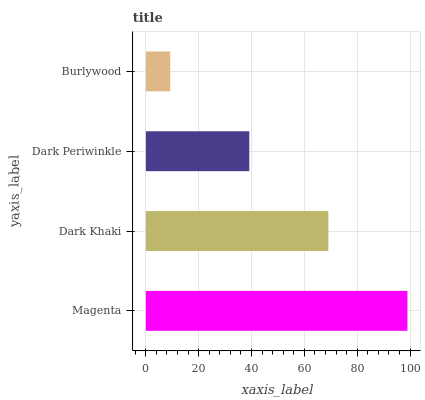Is Burlywood the minimum?
Answer yes or no. Yes. Is Magenta the maximum?
Answer yes or no. Yes. Is Dark Khaki the minimum?
Answer yes or no. No. Is Dark Khaki the maximum?
Answer yes or no. No. Is Magenta greater than Dark Khaki?
Answer yes or no. Yes. Is Dark Khaki less than Magenta?
Answer yes or no. Yes. Is Dark Khaki greater than Magenta?
Answer yes or no. No. Is Magenta less than Dark Khaki?
Answer yes or no. No. Is Dark Khaki the high median?
Answer yes or no. Yes. Is Dark Periwinkle the low median?
Answer yes or no. Yes. Is Magenta the high median?
Answer yes or no. No. Is Burlywood the low median?
Answer yes or no. No. 